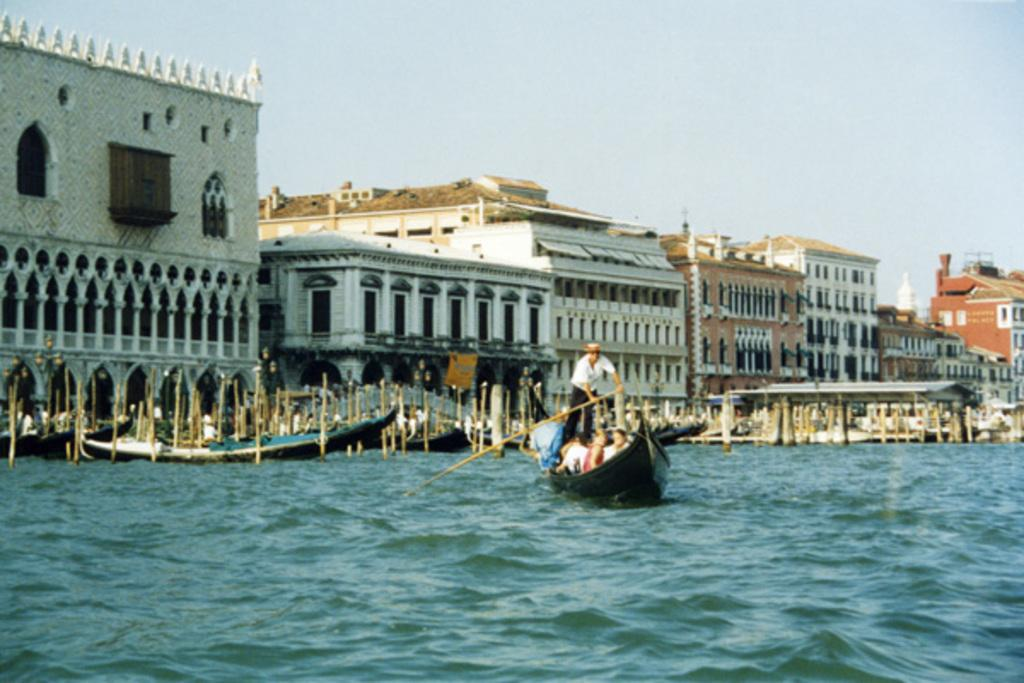What is the main feature of the image? There is water in the image. What structure can be seen crossing the water? There is a bridge in the image. Who or what is present near the water? There is a group of people in the image. What mode of transportation is visible in the image? There is a boat in the image. What else can be seen in the background of the image? There are buildings in the image. What is visible at the top of the image? The sky is visible at the top of the image. What type of fuel is being used by the horse in the image? There is no horse present in the image, so it is not possible to determine what type of fuel it might be using. 